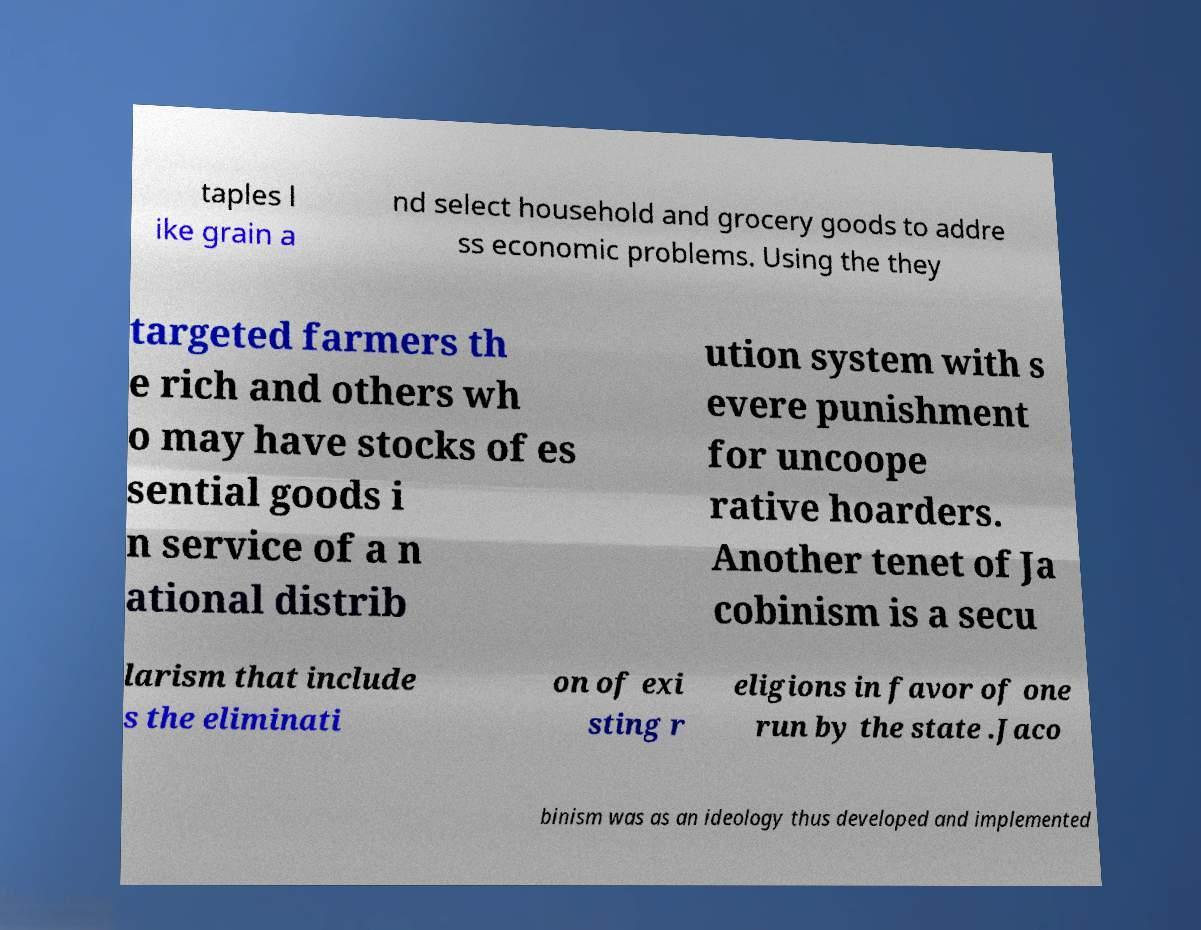For documentation purposes, I need the text within this image transcribed. Could you provide that? taples l ike grain a nd select household and grocery goods to addre ss economic problems. Using the they targeted farmers th e rich and others wh o may have stocks of es sential goods i n service of a n ational distrib ution system with s evere punishment for uncoope rative hoarders. Another tenet of Ja cobinism is a secu larism that include s the eliminati on of exi sting r eligions in favor of one run by the state .Jaco binism was as an ideology thus developed and implemented 